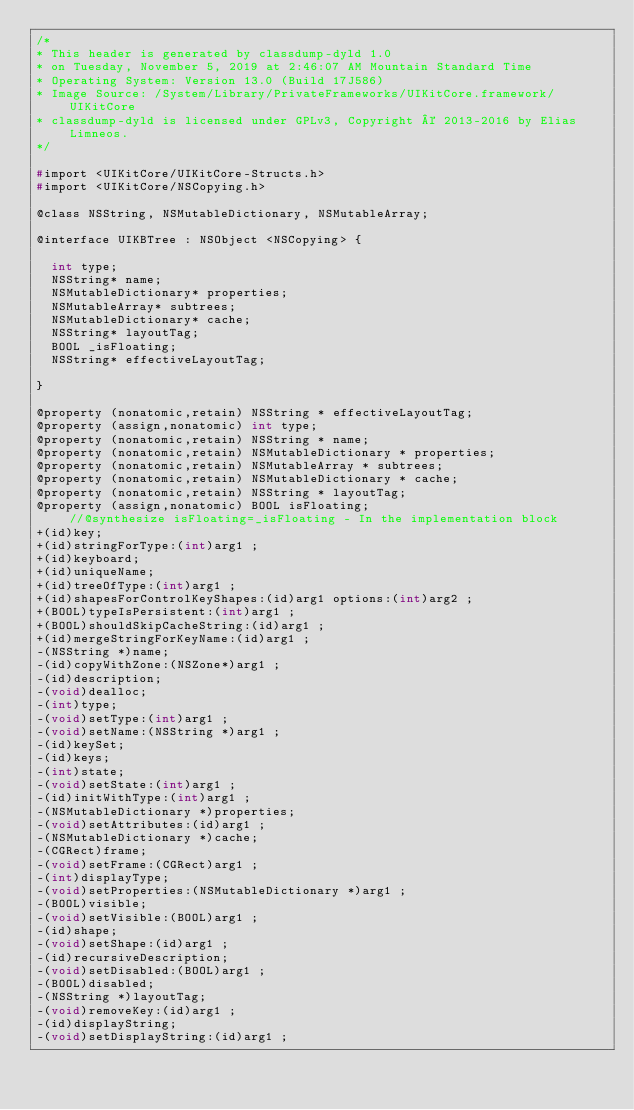<code> <loc_0><loc_0><loc_500><loc_500><_C_>/*
* This header is generated by classdump-dyld 1.0
* on Tuesday, November 5, 2019 at 2:46:07 AM Mountain Standard Time
* Operating System: Version 13.0 (Build 17J586)
* Image Source: /System/Library/PrivateFrameworks/UIKitCore.framework/UIKitCore
* classdump-dyld is licensed under GPLv3, Copyright © 2013-2016 by Elias Limneos.
*/

#import <UIKitCore/UIKitCore-Structs.h>
#import <UIKitCore/NSCopying.h>

@class NSString, NSMutableDictionary, NSMutableArray;

@interface UIKBTree : NSObject <NSCopying> {

	int type;
	NSString* name;
	NSMutableDictionary* properties;
	NSMutableArray* subtrees;
	NSMutableDictionary* cache;
	NSString* layoutTag;
	BOOL _isFloating;
	NSString* effectiveLayoutTag;

}

@property (nonatomic,retain) NSString * effectiveLayoutTag; 
@property (assign,nonatomic) int type; 
@property (nonatomic,retain) NSString * name; 
@property (nonatomic,retain) NSMutableDictionary * properties; 
@property (nonatomic,retain) NSMutableArray * subtrees; 
@property (nonatomic,retain) NSMutableDictionary * cache; 
@property (nonatomic,retain) NSString * layoutTag; 
@property (assign,nonatomic) BOOL isFloating;                               //@synthesize isFloating=_isFloating - In the implementation block
+(id)key;
+(id)stringForType:(int)arg1 ;
+(id)keyboard;
+(id)uniqueName;
+(id)treeOfType:(int)arg1 ;
+(id)shapesForControlKeyShapes:(id)arg1 options:(int)arg2 ;
+(BOOL)typeIsPersistent:(int)arg1 ;
+(BOOL)shouldSkipCacheString:(id)arg1 ;
+(id)mergeStringForKeyName:(id)arg1 ;
-(NSString *)name;
-(id)copyWithZone:(NSZone*)arg1 ;
-(id)description;
-(void)dealloc;
-(int)type;
-(void)setType:(int)arg1 ;
-(void)setName:(NSString *)arg1 ;
-(id)keySet;
-(id)keys;
-(int)state;
-(void)setState:(int)arg1 ;
-(id)initWithType:(int)arg1 ;
-(NSMutableDictionary *)properties;
-(void)setAttributes:(id)arg1 ;
-(NSMutableDictionary *)cache;
-(CGRect)frame;
-(void)setFrame:(CGRect)arg1 ;
-(int)displayType;
-(void)setProperties:(NSMutableDictionary *)arg1 ;
-(BOOL)visible;
-(void)setVisible:(BOOL)arg1 ;
-(id)shape;
-(void)setShape:(id)arg1 ;
-(id)recursiveDescription;
-(void)setDisabled:(BOOL)arg1 ;
-(BOOL)disabled;
-(NSString *)layoutTag;
-(void)removeKey:(id)arg1 ;
-(id)displayString;
-(void)setDisplayString:(id)arg1 ;</code> 